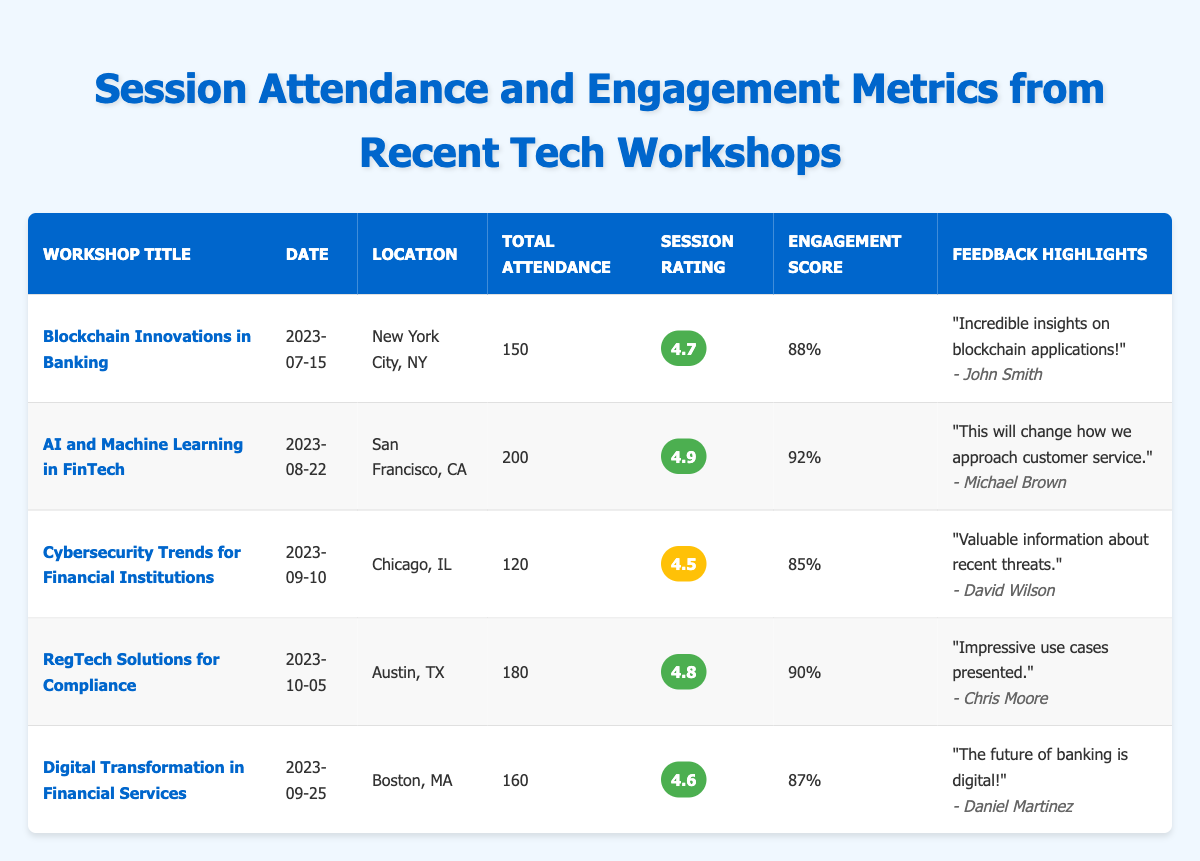What is the workshop with the highest engagement score? The engagement scores for each workshop are listed: 88, 92, 85, 90, and 87. The highest score is 92 for the "AI and Machine Learning in FinTech" workshop.
Answer: AI and Machine Learning in FinTech How many attendees were present at the "Cybersecurity Trends for Financial Institutions" workshop? The total attendance for the "Cybersecurity Trends for Financial Institutions" workshop is provided in the table, which states that there were 120 attendees.
Answer: 120 What is the average session rating of all workshops? The session ratings are: 4.7, 4.9, 4.5, 4.8, and 4.6. To find the average, sum them up (4.7 + 4.9 + 4.5 + 4.8 + 4.6 = 24.5) and divide by the number of workshops (5). So, 24.5 / 5 = 4.9.
Answer: 4.9 Did any workshop have a session rating lower than 4.5? The session ratings are: 4.7, 4.9, 4.5, 4.8, and 4.6. The lowest rating is 4.5, which is not lower than 4.5. Therefore, no workshop had a rating lower than this value.
Answer: No Which workshop had the highest attendance and what was the number of attendees? The total attendance numbers are: 150, 200, 120, 180, and 160. The highest attendance is 200 for the "AI and Machine Learning in FinTech" workshop.
Answer: 200 attendees for AI and Machine Learning in FinTech What is the difference in engagement scores between the "Blockchain Innovations in Banking" and "RegTech Solutions for Compliance" workshops? The engagement scores are 88 for "Blockchain Innovations in Banking" and 90 for "RegTech Solutions for Compliance." The difference is calculated as follows: 90 - 88 = 2.
Answer: 2 How many workshops were held in September? The workshops listed with dates in September are "Cybersecurity Trends for Financial Institutions" (September 10) and "Digital Transformation in Financial Services" (September 25). Therefore, there are two workshops in September.
Answer: 2 Which feedback comment was made by Emily Davis? The feedback comment made by Emily Davis is "Great panel discussion, very informative!" as noted in the table under the relevant workshop.
Answer: Great panel discussion, very informative! Is the session rating of the "Digital Transformation in Financial Services" higher than the average session rating? The session rating for "Digital Transformation in Financial Services" is 4.6, and the average session rating is calculated as 4.9. Since 4.6 is not higher than 4.9, the answer is no.
Answer: No Which workshop has the lowest session rating, and what was it? The session ratings are 4.7, 4.9, 4.5, 4.8, and 4.6. The lowest rating is 4.5, associated with the "Cybersecurity Trends for Financial Institutions" workshop.
Answer: Cybersecurity Trends for Financial Institutions, 4.5 